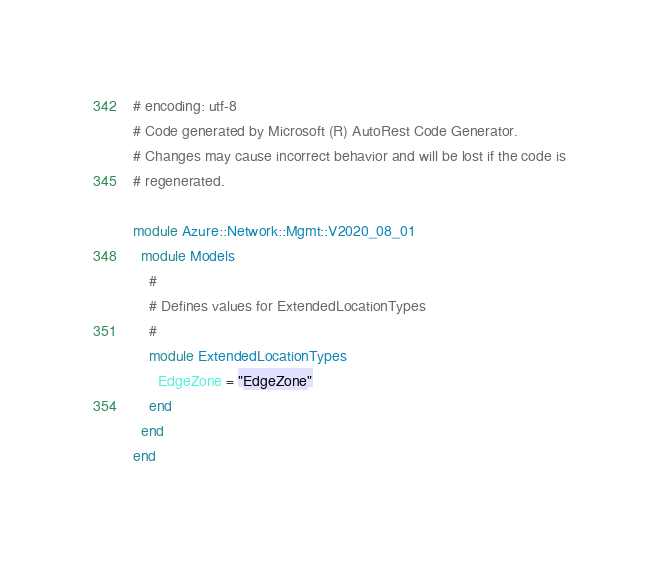Convert code to text. <code><loc_0><loc_0><loc_500><loc_500><_Ruby_># encoding: utf-8
# Code generated by Microsoft (R) AutoRest Code Generator.
# Changes may cause incorrect behavior and will be lost if the code is
# regenerated.

module Azure::Network::Mgmt::V2020_08_01
  module Models
    #
    # Defines values for ExtendedLocationTypes
    #
    module ExtendedLocationTypes
      EdgeZone = "EdgeZone"
    end
  end
end
</code> 